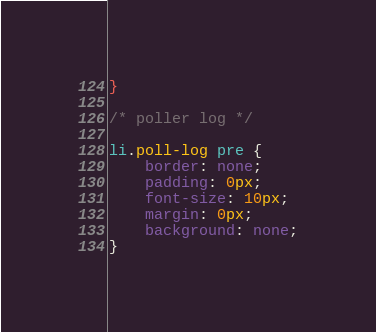Convert code to text. <code><loc_0><loc_0><loc_500><loc_500><_CSS_>}

/* poller log */

li.poll-log pre {
	border: none;
	padding: 0px;
	font-size: 10px;
	margin: 0px;
	background: none;
}
</code> 